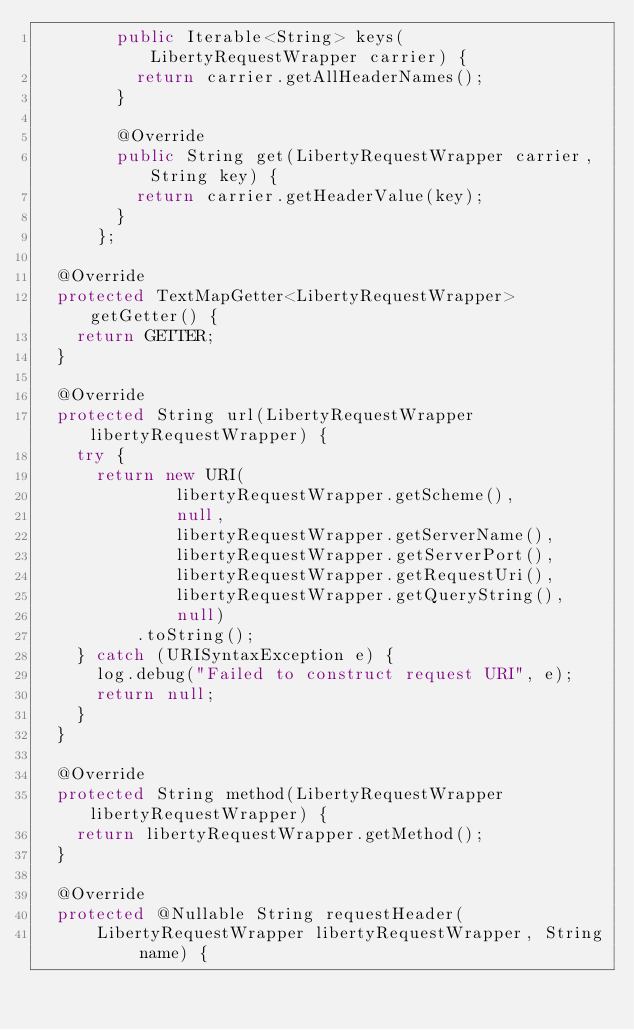<code> <loc_0><loc_0><loc_500><loc_500><_Java_>        public Iterable<String> keys(LibertyRequestWrapper carrier) {
          return carrier.getAllHeaderNames();
        }

        @Override
        public String get(LibertyRequestWrapper carrier, String key) {
          return carrier.getHeaderValue(key);
        }
      };

  @Override
  protected TextMapGetter<LibertyRequestWrapper> getGetter() {
    return GETTER;
  }

  @Override
  protected String url(LibertyRequestWrapper libertyRequestWrapper) {
    try {
      return new URI(
              libertyRequestWrapper.getScheme(),
              null,
              libertyRequestWrapper.getServerName(),
              libertyRequestWrapper.getServerPort(),
              libertyRequestWrapper.getRequestUri(),
              libertyRequestWrapper.getQueryString(),
              null)
          .toString();
    } catch (URISyntaxException e) {
      log.debug("Failed to construct request URI", e);
      return null;
    }
  }

  @Override
  protected String method(LibertyRequestWrapper libertyRequestWrapper) {
    return libertyRequestWrapper.getMethod();
  }

  @Override
  protected @Nullable String requestHeader(
      LibertyRequestWrapper libertyRequestWrapper, String name) {</code> 